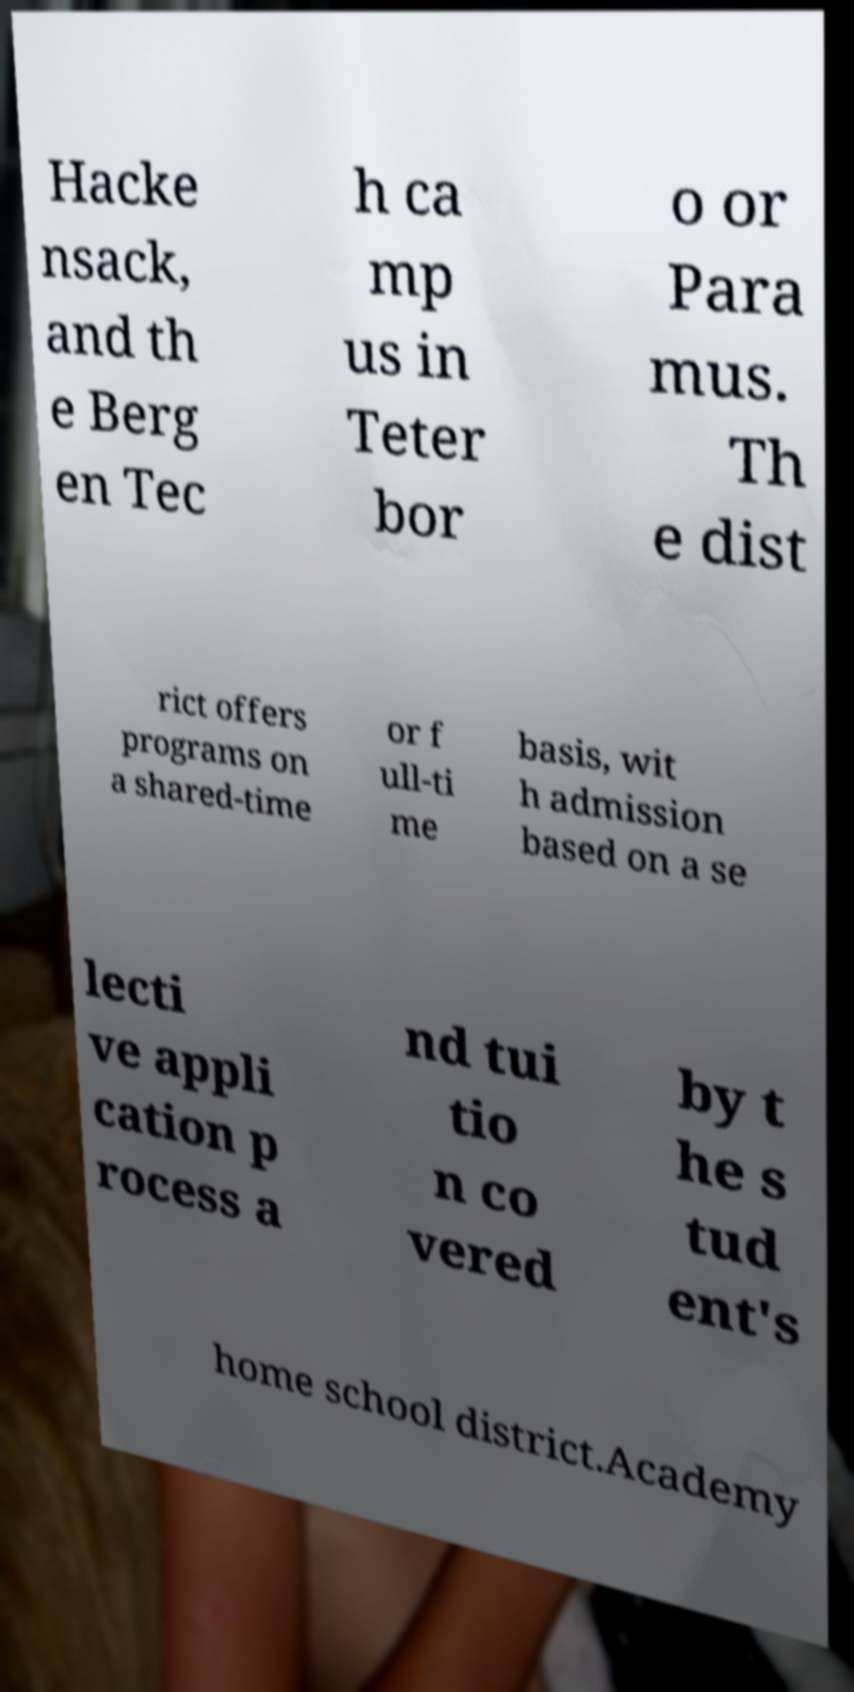For documentation purposes, I need the text within this image transcribed. Could you provide that? Hacke nsack, and th e Berg en Tec h ca mp us in Teter bor o or Para mus. Th e dist rict offers programs on a shared-time or f ull-ti me basis, wit h admission based on a se lecti ve appli cation p rocess a nd tui tio n co vered by t he s tud ent's home school district.Academy 